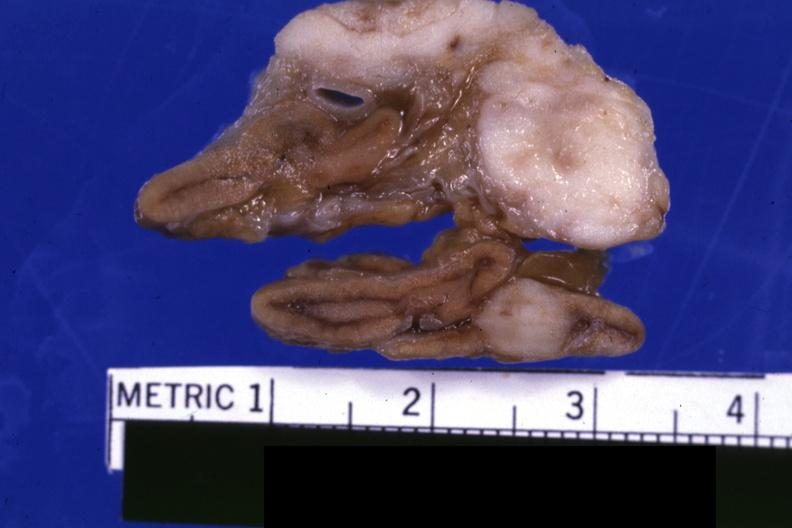s capillary present?
Answer the question using a single word or phrase. No 